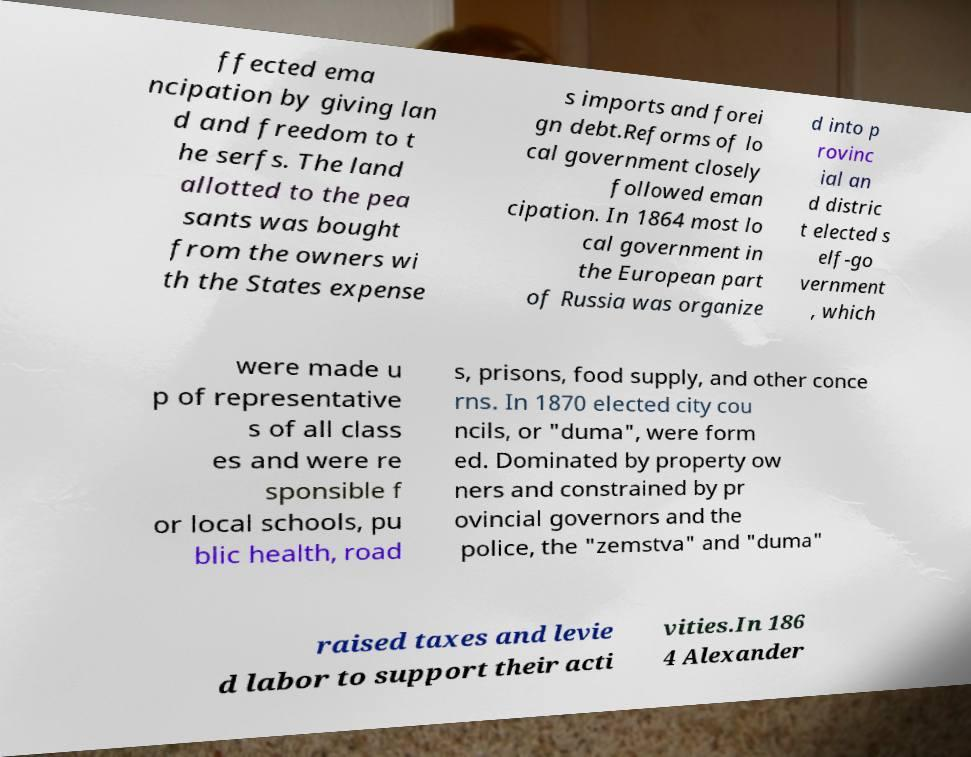What messages or text are displayed in this image? I need them in a readable, typed format. ffected ema ncipation by giving lan d and freedom to t he serfs. The land allotted to the pea sants was bought from the owners wi th the States expense s imports and forei gn debt.Reforms of lo cal government closely followed eman cipation. In 1864 most lo cal government in the European part of Russia was organize d into p rovinc ial an d distric t elected s elf-go vernment , which were made u p of representative s of all class es and were re sponsible f or local schools, pu blic health, road s, prisons, food supply, and other conce rns. In 1870 elected city cou ncils, or "duma", were form ed. Dominated by property ow ners and constrained by pr ovincial governors and the police, the "zemstva" and "duma" raised taxes and levie d labor to support their acti vities.In 186 4 Alexander 